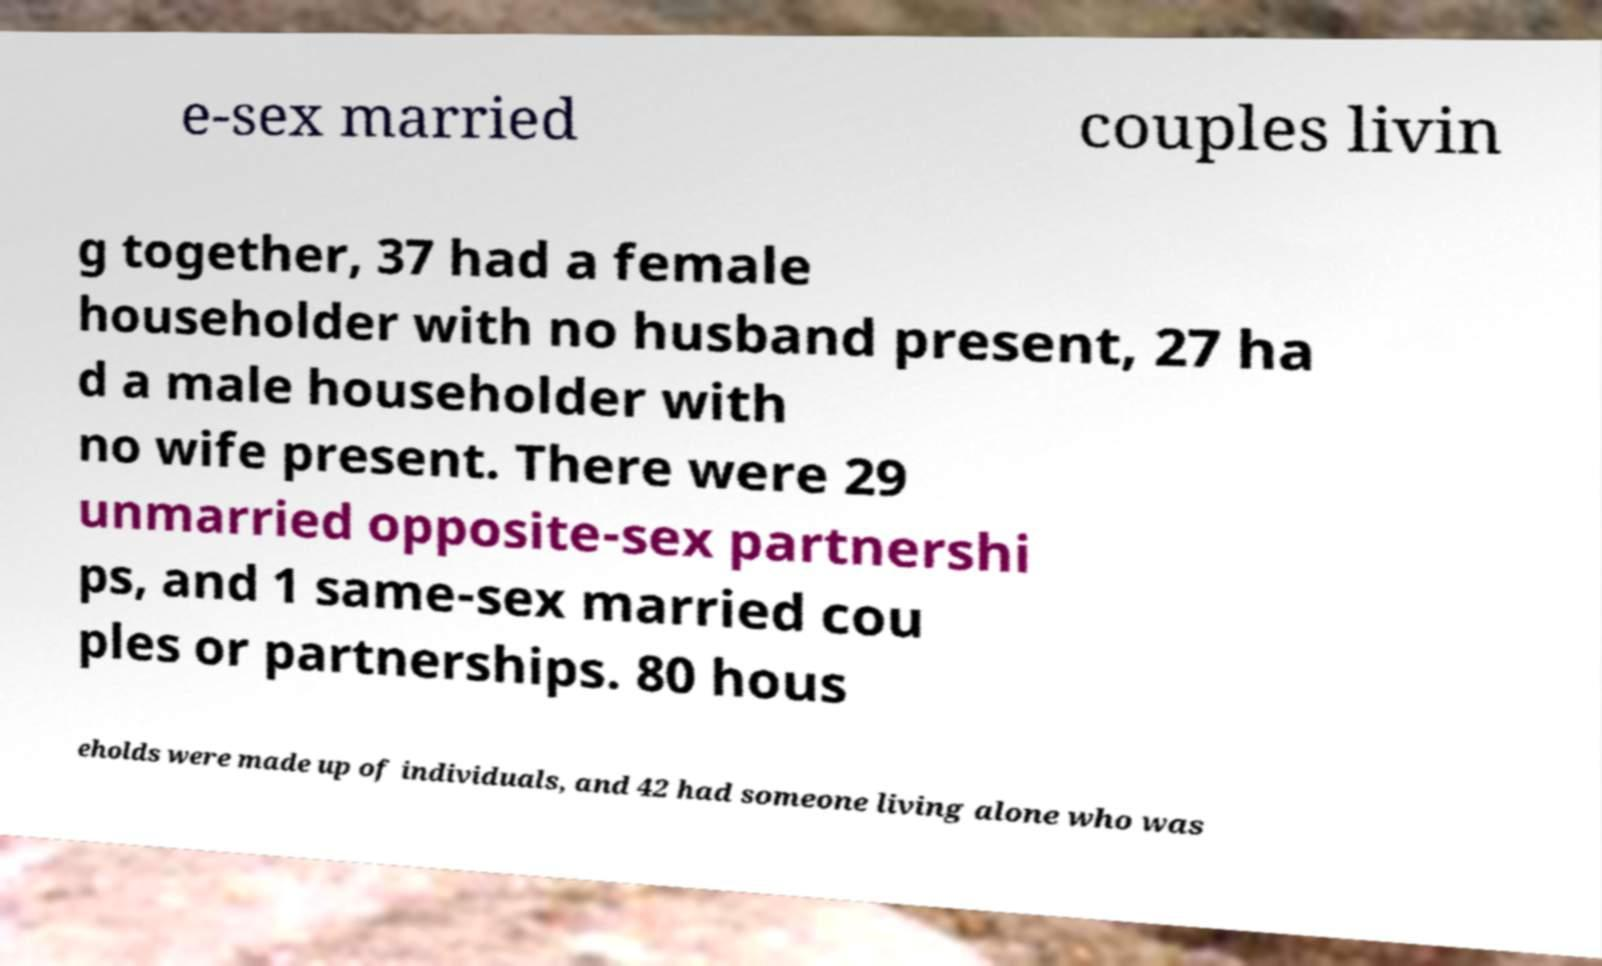Please read and relay the text visible in this image. What does it say? e-sex married couples livin g together, 37 had a female householder with no husband present, 27 ha d a male householder with no wife present. There were 29 unmarried opposite-sex partnershi ps, and 1 same-sex married cou ples or partnerships. 80 hous eholds were made up of individuals, and 42 had someone living alone who was 